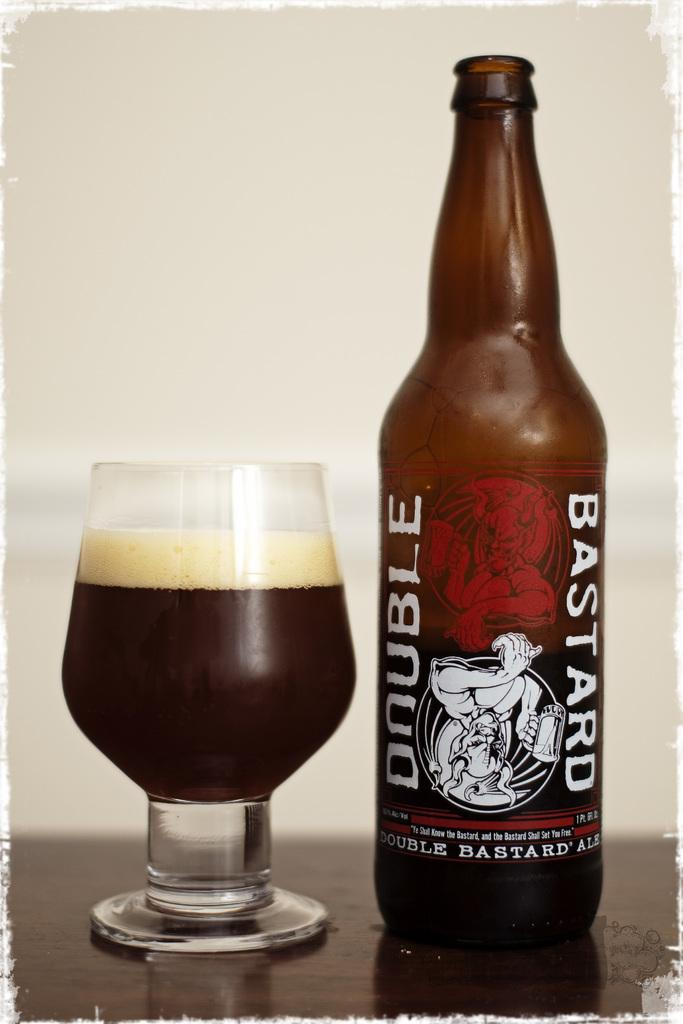<image>
Offer a succinct explanation of the picture presented. A full glass of Bastard Double ale next to the beer bottle. 